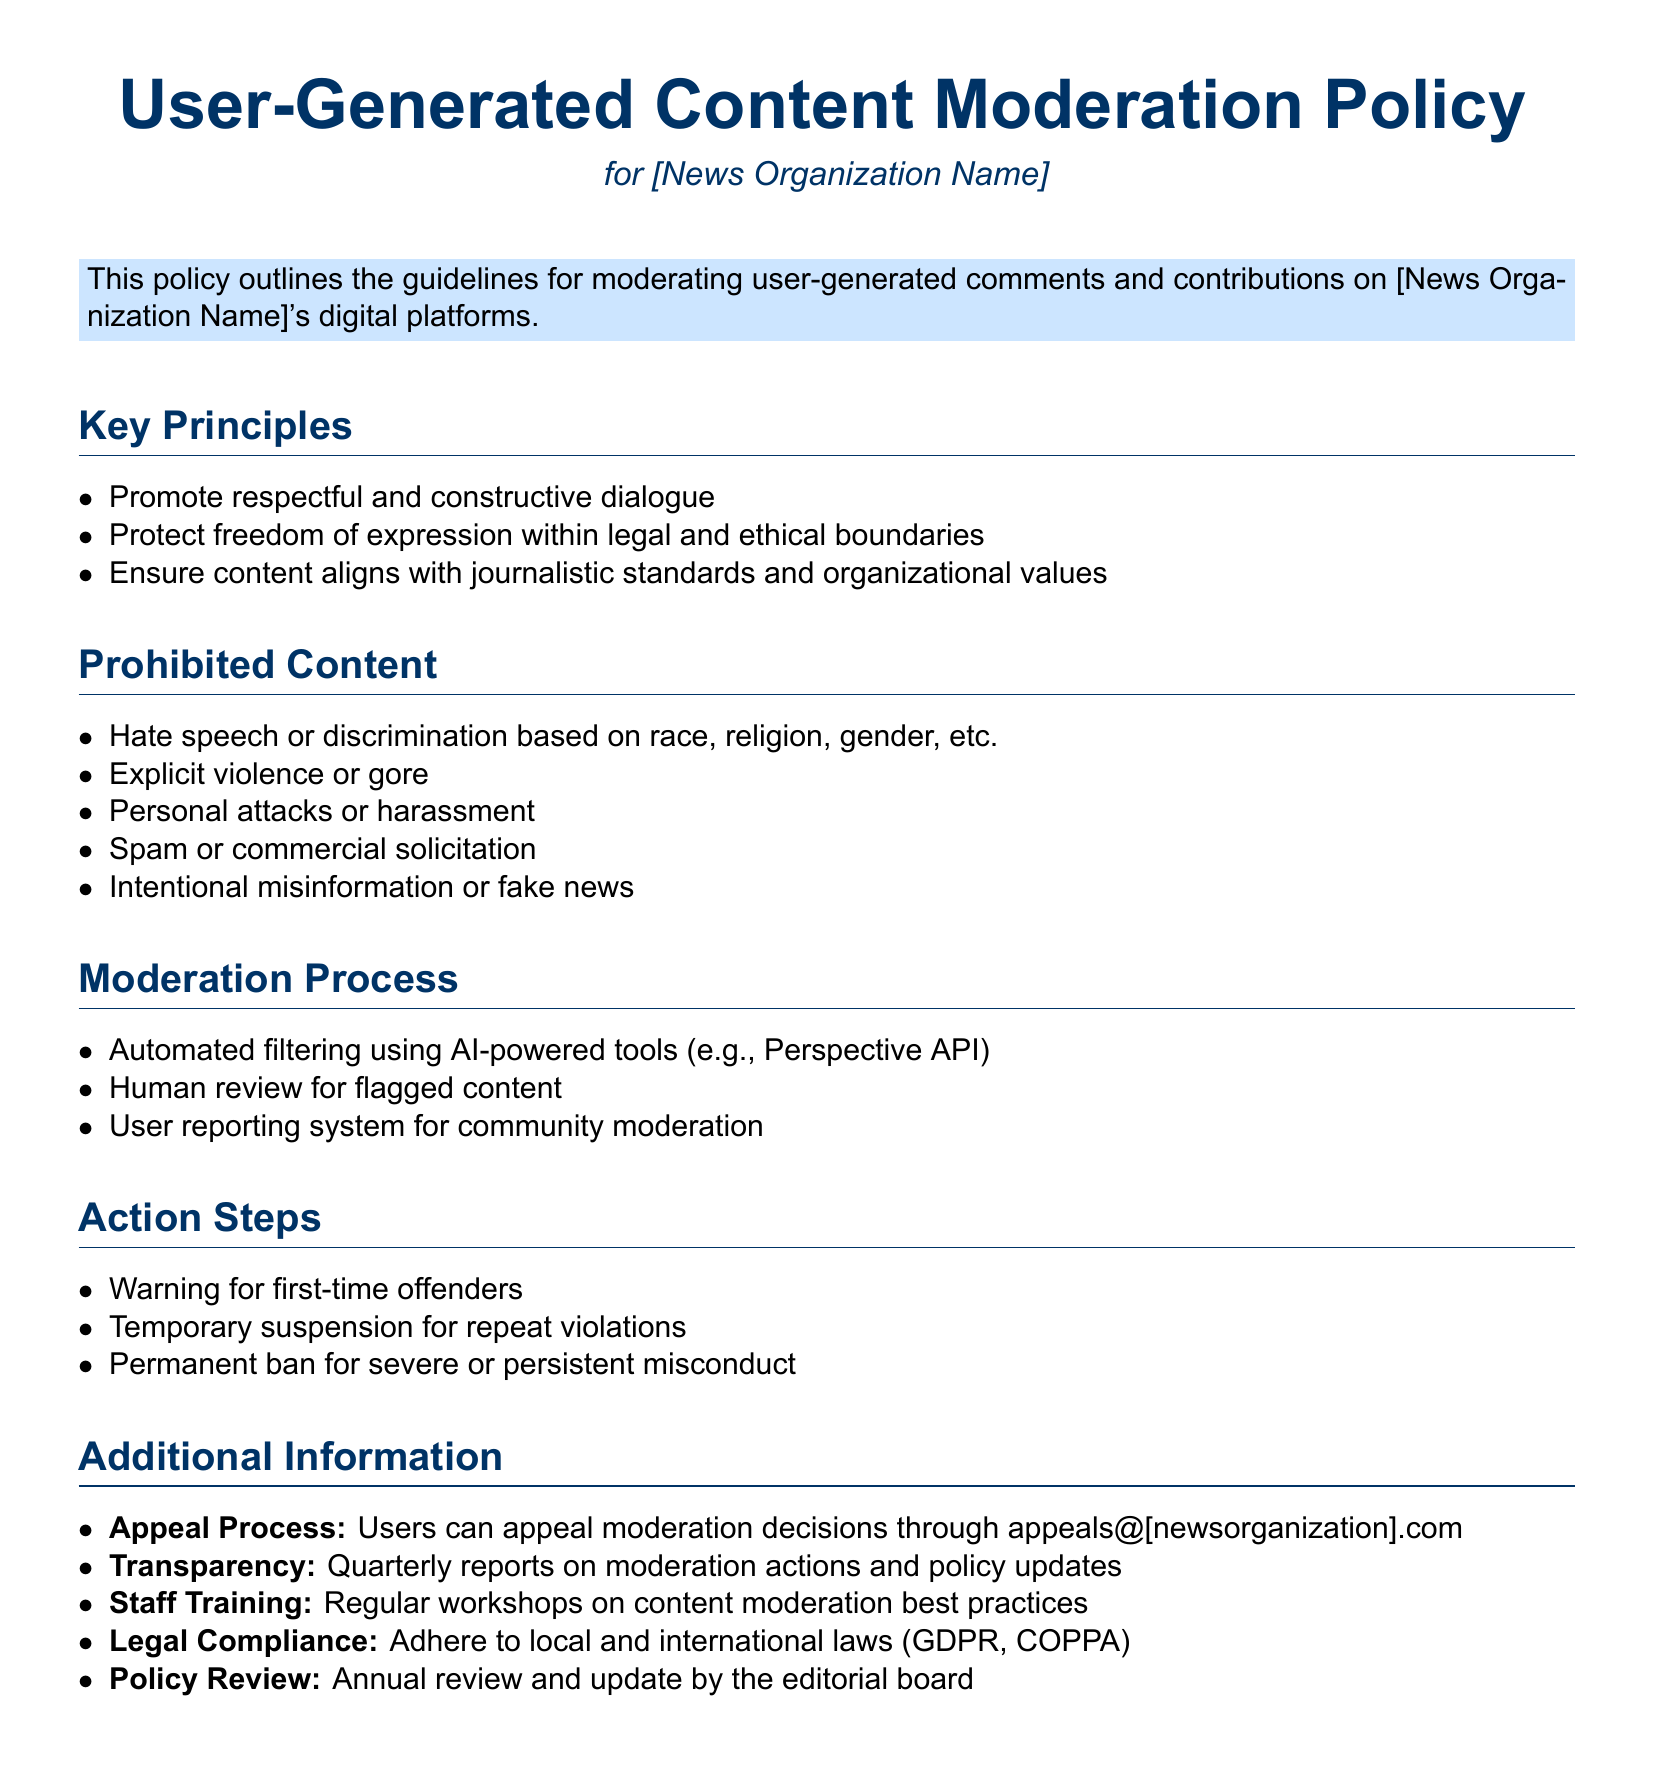What are the key principles of this policy? The key principles are the guiding philosophies for moderation as outlined in the document.
Answer: Promote respectful and constructive dialogue, Protect freedom of expression within legal and ethical boundaries, Ensure content aligns with journalistic standards and organizational values What type of content is prohibited? The prohibited content section lists the types of contributions that cannot be accepted according to the policy.
Answer: Hate speech or discrimination based on race, religion, gender, etc., Explicit violence or gore, Personal attacks or harassment, Spam or commercial solicitation, Intentional misinformation or fake news What is the first action step for repeat offenders? The action steps outline the consequences for users who violate the moderation policy.
Answer: Temporary suspension for repeat violations How can users appeal moderation decisions? The additional information section specifies the method for users to contest moderation actions.
Answer: appeals@[newsorganization].com How often will moderation actions and policy updates be reported? The transparency section provides information about the frequency of reporting on moderation actions.
Answer: Quarterly reports 